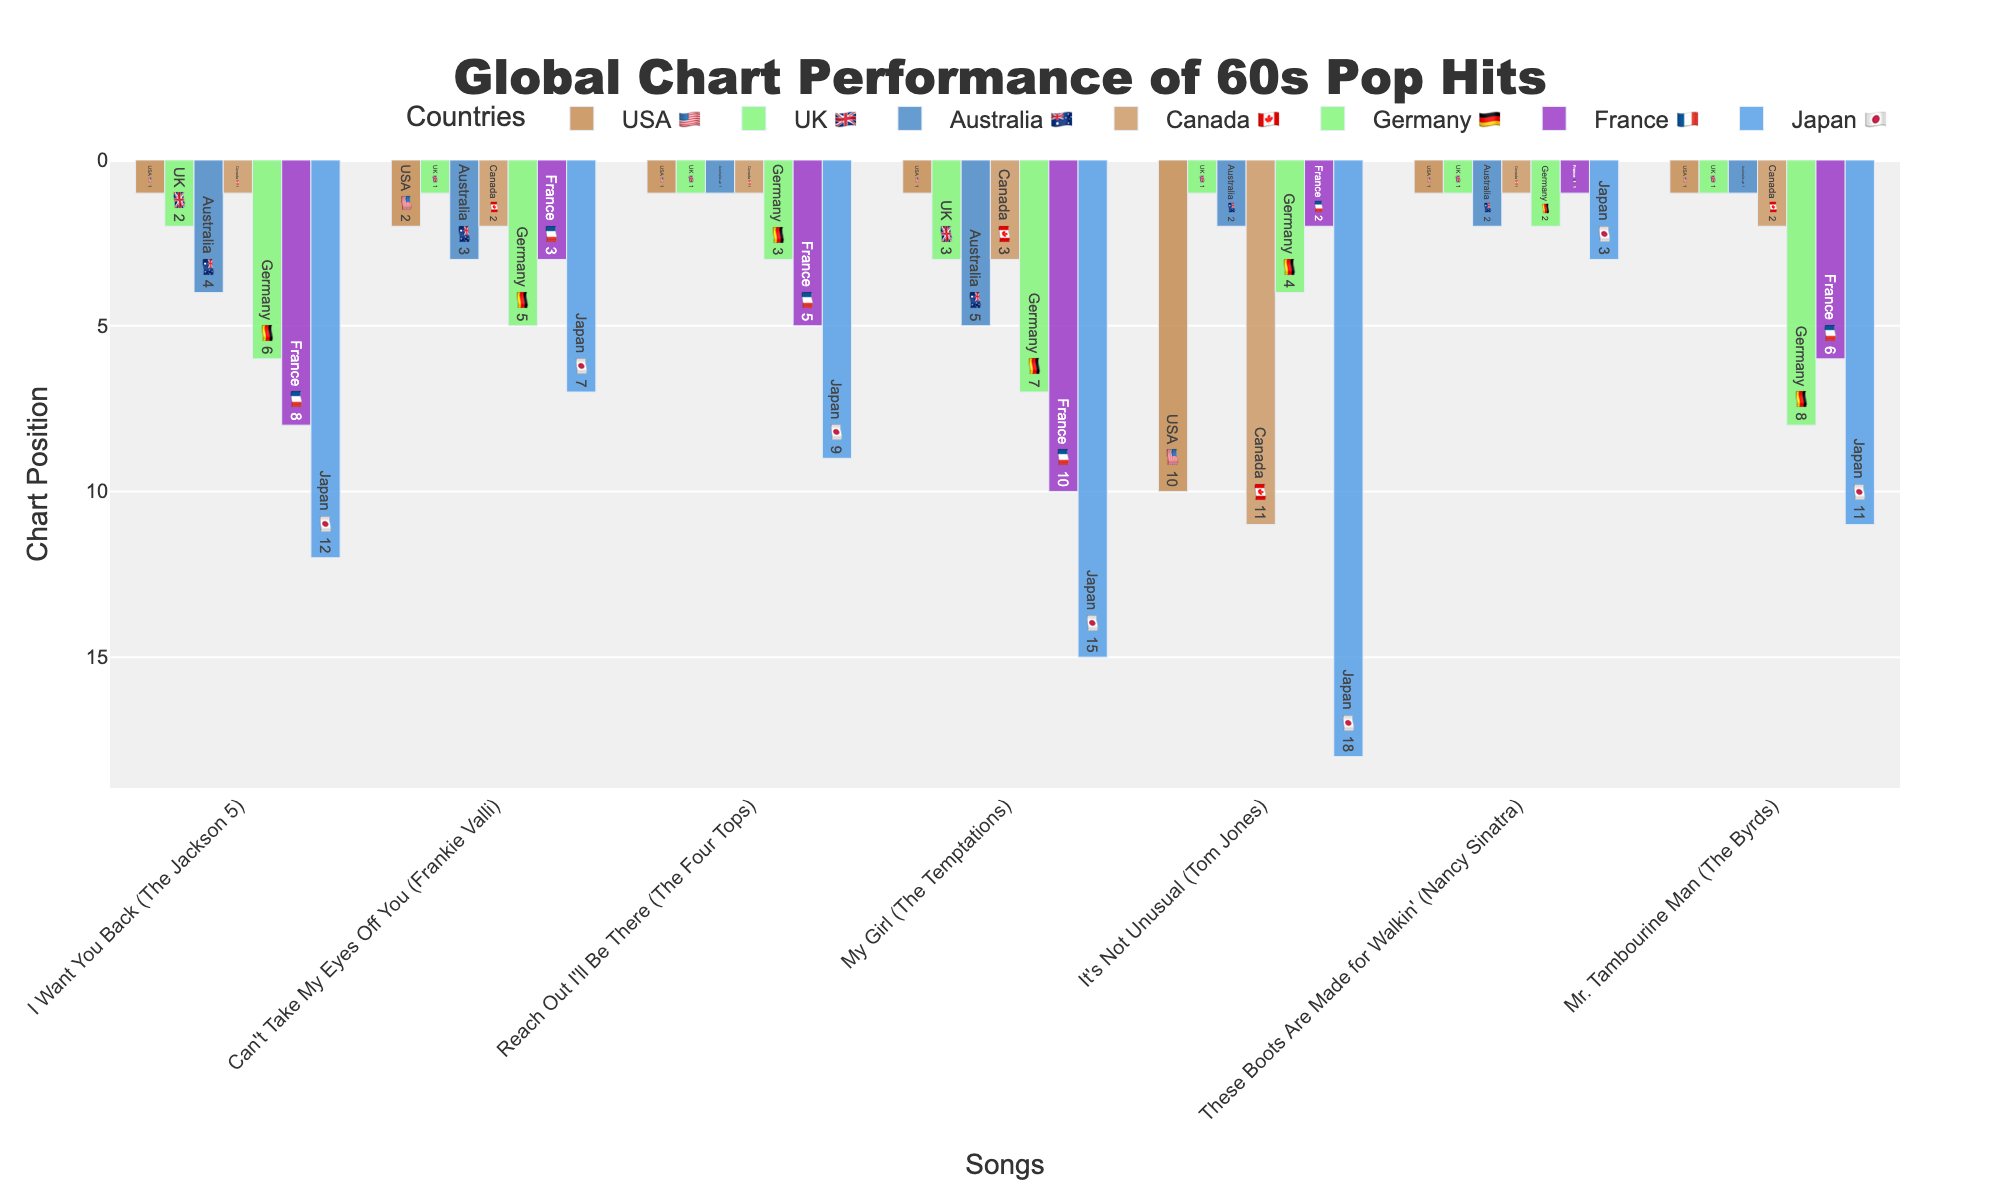Which song has the best average chart position across all countries? To find the song with the best average chart position, we should calculate the average position for each song across the seven countries and then identify the lowest average value (highest chart performance). For "I Want You Back" (1+2+4+1+6+8+12)/7 = 4.86, for "Can't Take My Eyes Off You" (2+1+3+2+5+3+7)/7 = 3.29, for "Reach Out I'll Be There" (1+1+1+1+3+5+9)/7 = 3, for "My Girl" (1+3+5+3+7+10+15)/7 = 6.29, for "It's Not Unusual" (10+1+2+11+4+2+18)/7 = 6.86, for "These Boots Are Made for Walkin'" (1+1+2+1+2+1+3)/7 = 1.57, for "Mr. Tambourine Man" (1+1+1+2+8+6+11)/7 = 4.29. Therefore, "These Boots Are Made for Walkin'" has the lowest average.
Answer: "These Boots Are Made for Walkin'" Which country has the most number of songs that reached number 1? Look at the chart positions for each country and count the number of times the position is 1. USA 🇺🇸: 5, UK 🇬🇧: 4, Australia 🇦🇺: 3, Canada 🇨🇦: 3, Germany 🇩🇪: 0, France 🇫🇷: 1, Japan 🇯🇵: 0. USA 🇺🇸 has the most number 1s.
Answer: USA 🇺🇸 Which song had the highest chart position in Japan 🇯🇵? Refer to the Japan 🇯🇵 column in the chart to find the lowest position number (highest ranking). "I Want You Back" has position 12, "Can't Take My Eyes Off You" has position 7, "Reach Out I'll Be There" has position 9, "My Girl" has position 15, "It's Not Unusual" has position 18, "These Boots Are Made for Walkin'" has position 3, "Mr. Tambourine Man" has position 11. The highest chart position in Japan 🇯🇵 is for "These Boots Are Made for Walkin'" at position 3.
Answer: "These Boots Are Made for Walkin'" How many songs have charted in the top 3 in both the USA 🇺🇸 and the UK 🇬🇧? Check the top 3 positions in both USA 🇺🇸 and UK 🇬🇧 columns. The songs in the top 3 in the USA 🇺🇸 are "I Want You Back," "Can't Take My Eyes Off You," "Reach Out I'll Be There," "My Girl," "These Boots Are Made for Walkin'," "Mr. Tambourine Man." The songs in the top 3 in the UK 🇬🇧 are "I Want You Back," "Can't Take My Eyes Off You," "Reach Out I'll Be There," "My Girl," "It's Not Unusual," "These Boots Are Made for Walkin'," "Mr. Tambourine Man." The songs appearing in both lists are "I Want You Back," "Can't Take My Eyes Off You," "Reach Out I'll Be There," "These Boots Are Made for Walkin'," and "Mr. Tambourine Man," totaling 5 songs.
Answer: 5 Which song had the lowest chart position in France 🇫🇷 and what was it? Refer to the France 🇫🇷 column and identify the highest number. "I Want You Back" has position 8, "Can't Take My Eyes Off You" has position 3, "Reach Out I'll Be There" has position 5, "My Girl" has position 10, "It's Not Unusual" has position 2, "These Boots Are Made for Walkin'" has position 1, "Mr. Tambourine Man" has position 6. The song with the lowest position (highest number) in France 🇫🇷 is "My Girl" at position 10.
Answer: "My Girl", 10 Which countries had the song "Reach Out I'll Be There" at number 1? Review the positions for the song "Reach Out I'll Be There" across all countries. USA 🇺🇸: 1, UK 🇬🇧: 1, Australia 🇦🇺: 1, Canada 🇨🇦: 1, Germany 🇩🇪: 3, France 🇫🇷: 5, Japan 🇯🇵: 9. The countries where it reached number 1 are USA 🇺🇸, UK 🇬🇧, Australia 🇦🇺, and Canada 🇨🇦.
Answer: USA 🇺🇸, UK 🇬🇧, Australia 🇦🇺, Canada 🇨🇦 